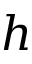<formula> <loc_0><loc_0><loc_500><loc_500>h</formula> 